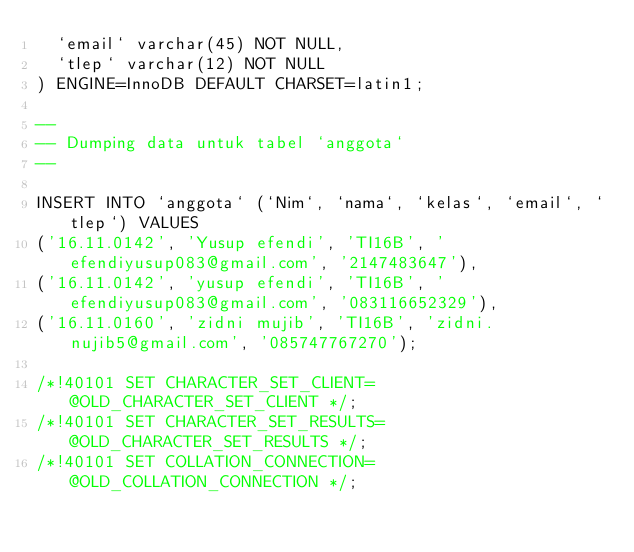Convert code to text. <code><loc_0><loc_0><loc_500><loc_500><_SQL_>  `email` varchar(45) NOT NULL,
  `tlep` varchar(12) NOT NULL
) ENGINE=InnoDB DEFAULT CHARSET=latin1;

--
-- Dumping data untuk tabel `anggota`
--

INSERT INTO `anggota` (`Nim`, `nama`, `kelas`, `email`, `tlep`) VALUES
('16.11.0142', 'Yusup efendi', 'TI16B', 'efendiyusup083@gmail.com', '2147483647'),
('16.11.0142', 'yusup efendi', 'TI16B', 'efendiyusup083@gmail.com', '083116652329'),
('16.11.0160', 'zidni mujib', 'TI16B', 'zidni.nujib5@gmail.com', '085747767270');

/*!40101 SET CHARACTER_SET_CLIENT=@OLD_CHARACTER_SET_CLIENT */;
/*!40101 SET CHARACTER_SET_RESULTS=@OLD_CHARACTER_SET_RESULTS */;
/*!40101 SET COLLATION_CONNECTION=@OLD_COLLATION_CONNECTION */;
</code> 